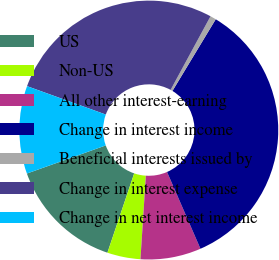Convert chart. <chart><loc_0><loc_0><loc_500><loc_500><pie_chart><fcel>US<fcel>Non-US<fcel>All other interest-earning<fcel>Change in interest income<fcel>Beneficial interests issued by<fcel>Change in interest expense<fcel>Change in net interest income<nl><fcel>14.37%<fcel>4.15%<fcel>7.56%<fcel>34.82%<fcel>0.74%<fcel>27.4%<fcel>10.96%<nl></chart> 